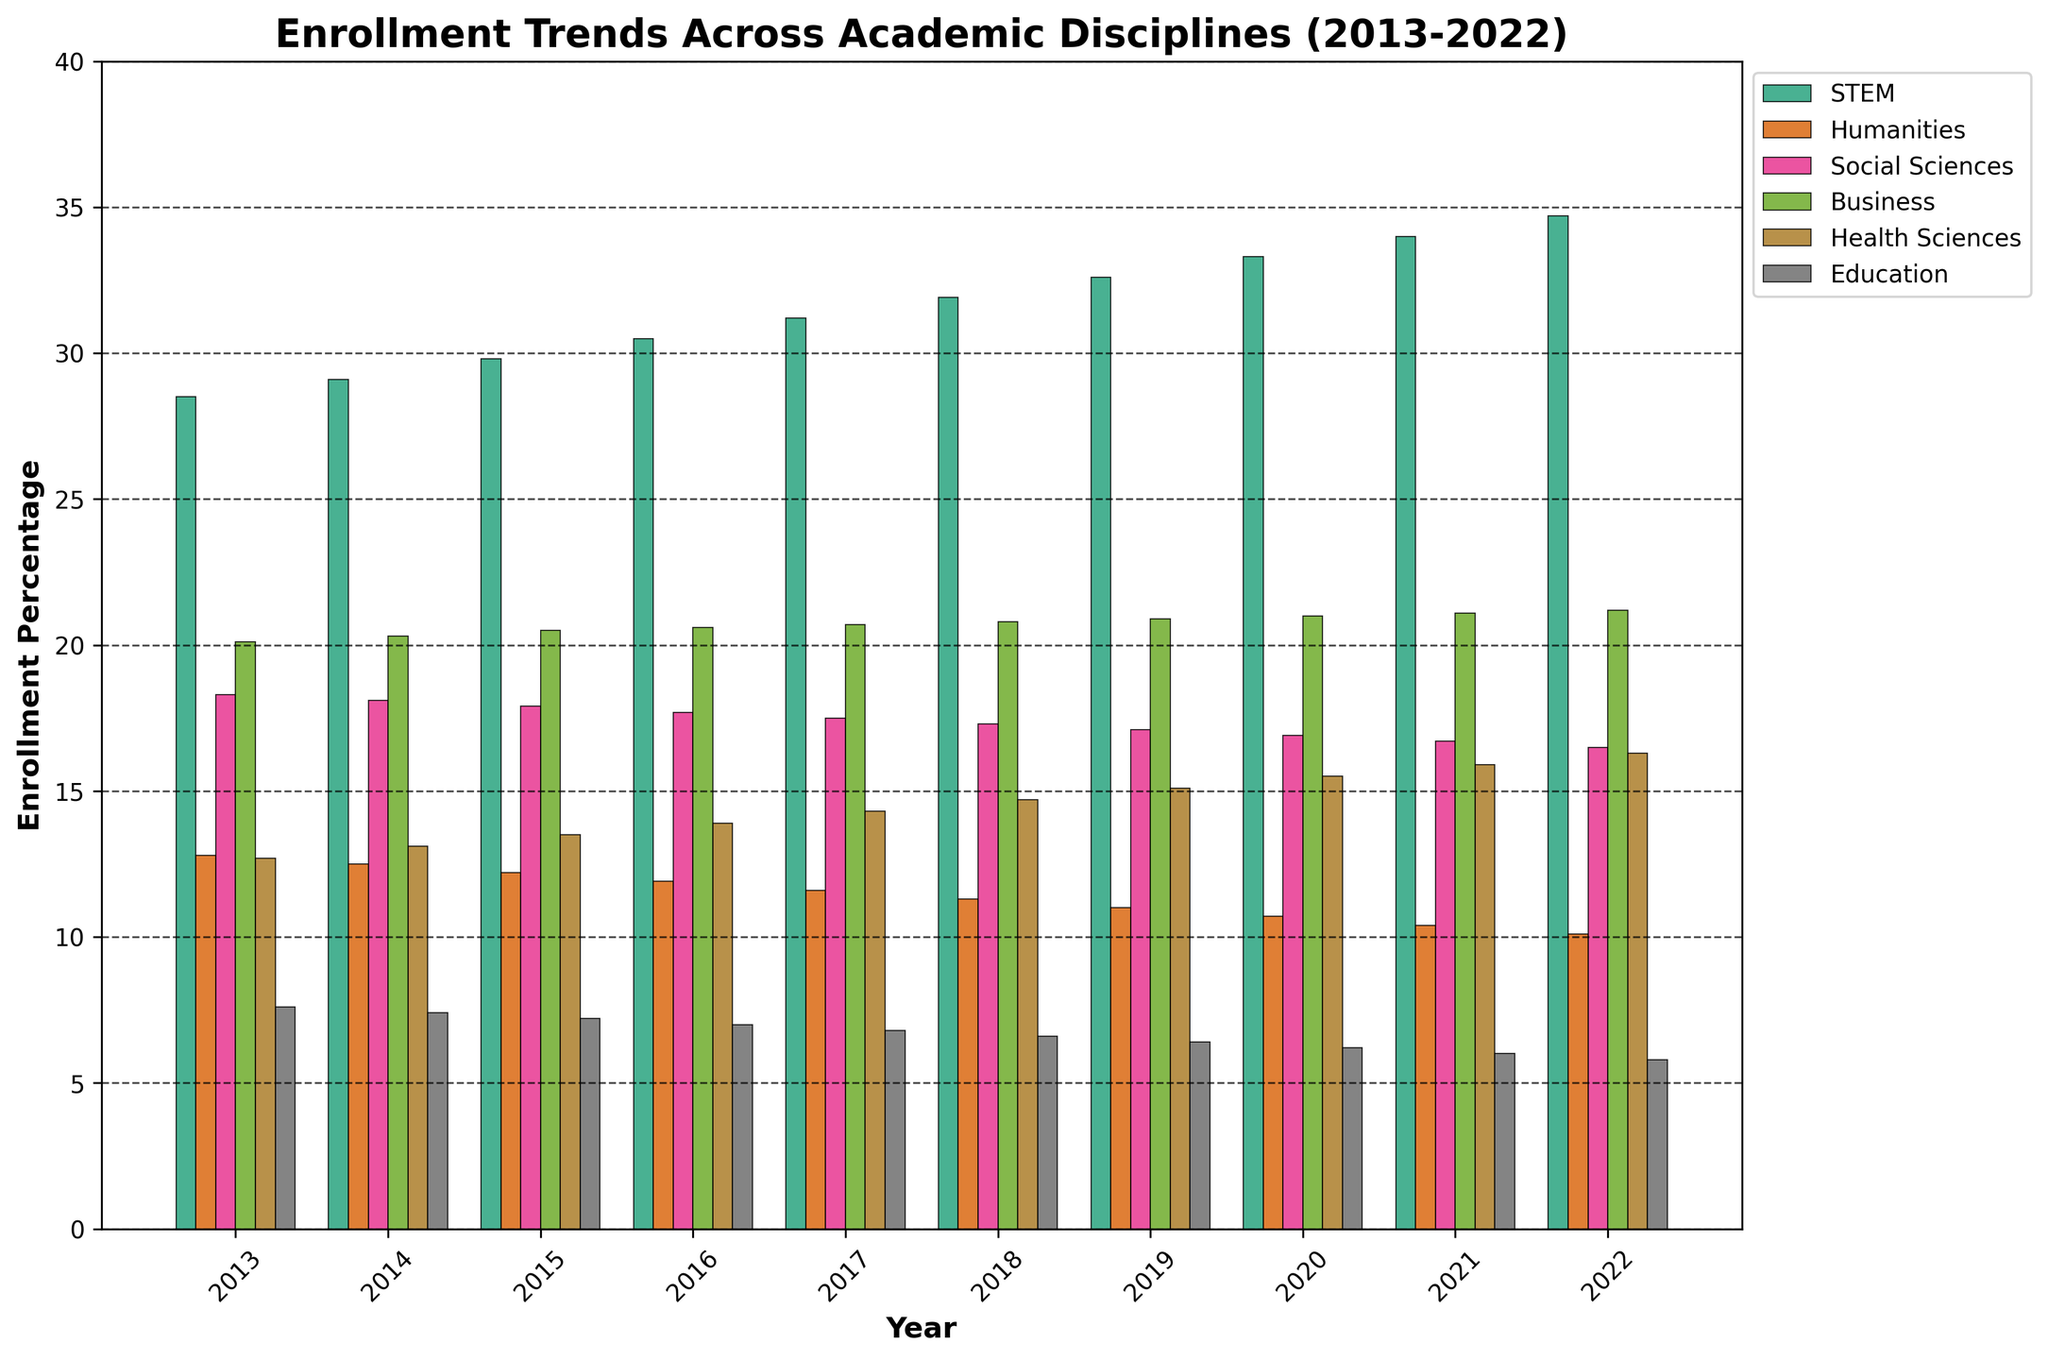Which discipline had the highest enrollment percentage in 2022? To determine the highest enrollment percentage in 2022, look at the top of the bars for each discipline in 2022. STEM has the tallest bar.
Answer: STEM Which discipline shows a consistent decline in enrollment percentage over the past decade? To find the discipline with consistent decline, observe the trend for each discipline from 2013 to 2022. Humanities shows a steady decrease over the years.
Answer: Humanities What is the average enrollment percentage for Health Sciences from 2013 to 2022? Calculate the average by summing the enrollment percentages for Health Sciences from 2013 to 2022: (12.7 + 13.1 + 13.5 + 13.9 + 14.3 + 14.7 + 15.1 + 15.5 + 15.9 + 16.3) and then dividing by the total number of years (10).
Answer: 14.5 In which year did Business reach its peak enrollment percentage? Find the tallest bar in the Business category: From 2013 to 2022, Business shows a slight increase, peaking in 2022.
Answer: 2022 Compare the enrollment percentages of STEM and Education in 2013. What is the difference? Look at the enrollment percentages of STEM (28.5) and Education (7.6) in 2013. Subtract the value of Education from the value of STEM: 28.5 - 7.6.
Answer: 20.9 Which discipline had the closest enrollment percentage to 18% in 2021? Look for the bar closest to the 18% mark in the 2021 columns. Social Sciences are just below at approximately 16.7%.
Answer: Social Sciences How much did the enrollment percentage for STEM increase between 2013 and 2022? Calculate the difference in enrollment percentage for STEM between 2013 (28.5) and 2022 (34.7): 34.7 - 28.5.
Answer: 6.2 Compare the tallest and shortest bars in 2017. What are the corresponding disciplines? The tallest bar in 2017 is STEM, and the shortest bar is Education.
Answer: STEM (tallest) and Education (shortest) Which year showed the most significant increase in Business enrollment compared to the previous year? Compare the incremental differences year over year for Business enrollment percentages. The increase from 2019 to 2020 (20.9 to 21.0) and subsequent years was relatively small, consistently around 0.1%.
Answer: 2019-2020 Which discipline showed the least variation in enrollment percentage over the decade? Observe the range of changes for each discipline. Education showed the smallest range of values from 2013 (7.6) to 2022 (5.8), indicating the least variation.
Answer: Education 